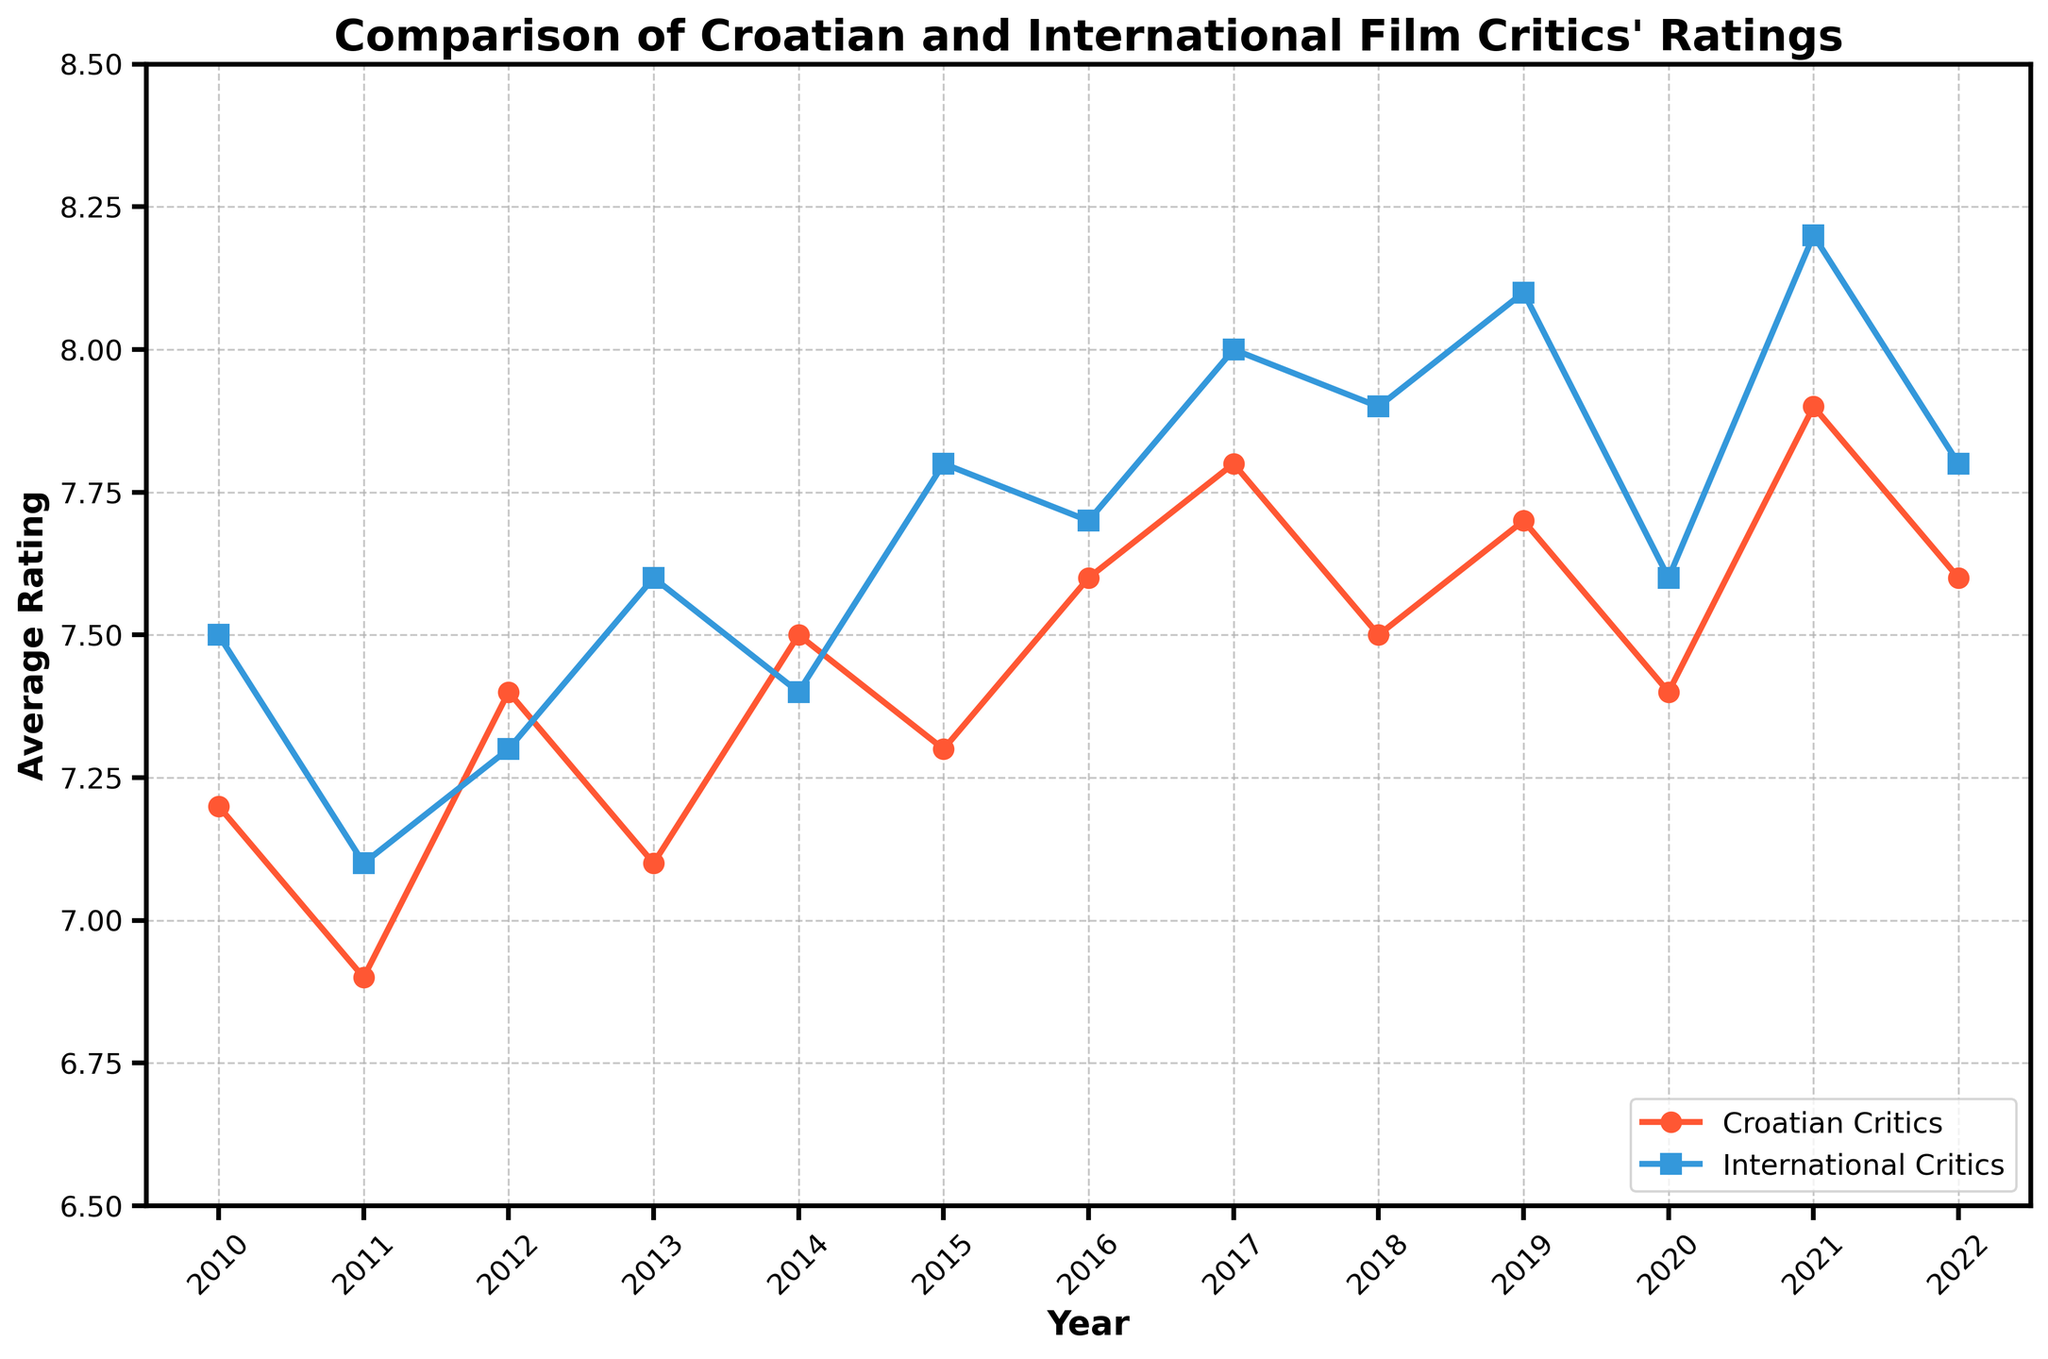What year did Croatian critics give the highest average rating? Croatian critics gave the highest average rating in 2021, as seen from the peak value on the red line in the figure.
Answer: 2021 Which year shows the largest difference between Croatian and international critics' ratings? In 2019, the difference between Croatian (7.7) and international critics' ratings (8.1) is the largest, which is 0.4.
Answer: 2019 During which years did Croatian critics' ratings increase compared to the previous year? List all such years. Croatian critics' ratings increased from 2011 to 2012 (6.9 to 7.4), 2013 to 2014 (7.1 to 7.5), 2015 to 2016 (7.3 to 7.6), 2016 to 2017 (7.6 to 7.8), 2019 to 2020 (7.7 to 7.4), and 2021 to 2022 (7.9 to 7.6).
Answer: 2012, 2014, 2016, 2017, 2019, 2022 How do the overall trends of Croatian and international critics' ratings compare from 2010 to 2022? Both trends generally show an upward movement, with international critics' ratings consistently higher than Croatian critics' ratings, except for minor fluctuations.
Answer: Upward for both with international higher Calculate the average rating over the years for Croatian critics. Summing up Croatian ratings (7.2 + 6.9 + 7.4 + 7.1 + 7.5 + 7.3 + 7.6 + 7.8 + 7.5 + 7.7 + 7.4 + 7.9 + 7.6) gives 93.9; dividing by 13 years results in an average of 7.23.
Answer: 7.23 In which year was the difference between Croatian and international critics' ratings the smallest? In 2012, the difference was smallest; Croatian critics rated 7.4 and international critics rated 7.3, with a difference of -0.1.
Answer: 2012 Which year shows the highest rating by international critics and what is that rating? International critics gave the highest rating in 2021, which is 8.2.
Answer: 2021 What is the difference between the highest and lowest ratings given by Croatian critics across all years? The highest rating by Croatian critics is 7.9 (2021) and the lowest is 6.9 (2011), so the difference is 7.9 - 6.9 = 1.0.
Answer: 1.0 